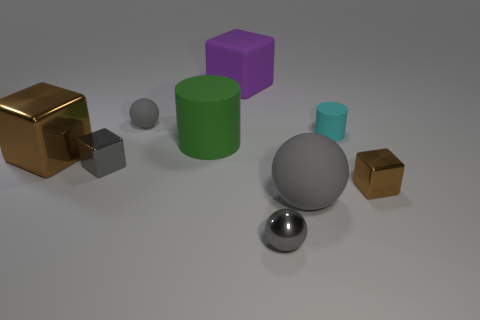Subtract all tiny gray balls. How many balls are left? 1 Subtract all green cylinders. How many cylinders are left? 1 Subtract 2 spheres. How many spheres are left? 1 Subtract all spheres. How many objects are left? 6 Subtract all yellow blocks. How many cyan balls are left? 0 Subtract all big green things. Subtract all tiny gray rubber things. How many objects are left? 7 Add 5 brown metal blocks. How many brown metal blocks are left? 7 Add 5 small shiny spheres. How many small shiny spheres exist? 6 Subtract 0 blue blocks. How many objects are left? 9 Subtract all purple cubes. Subtract all yellow cylinders. How many cubes are left? 3 